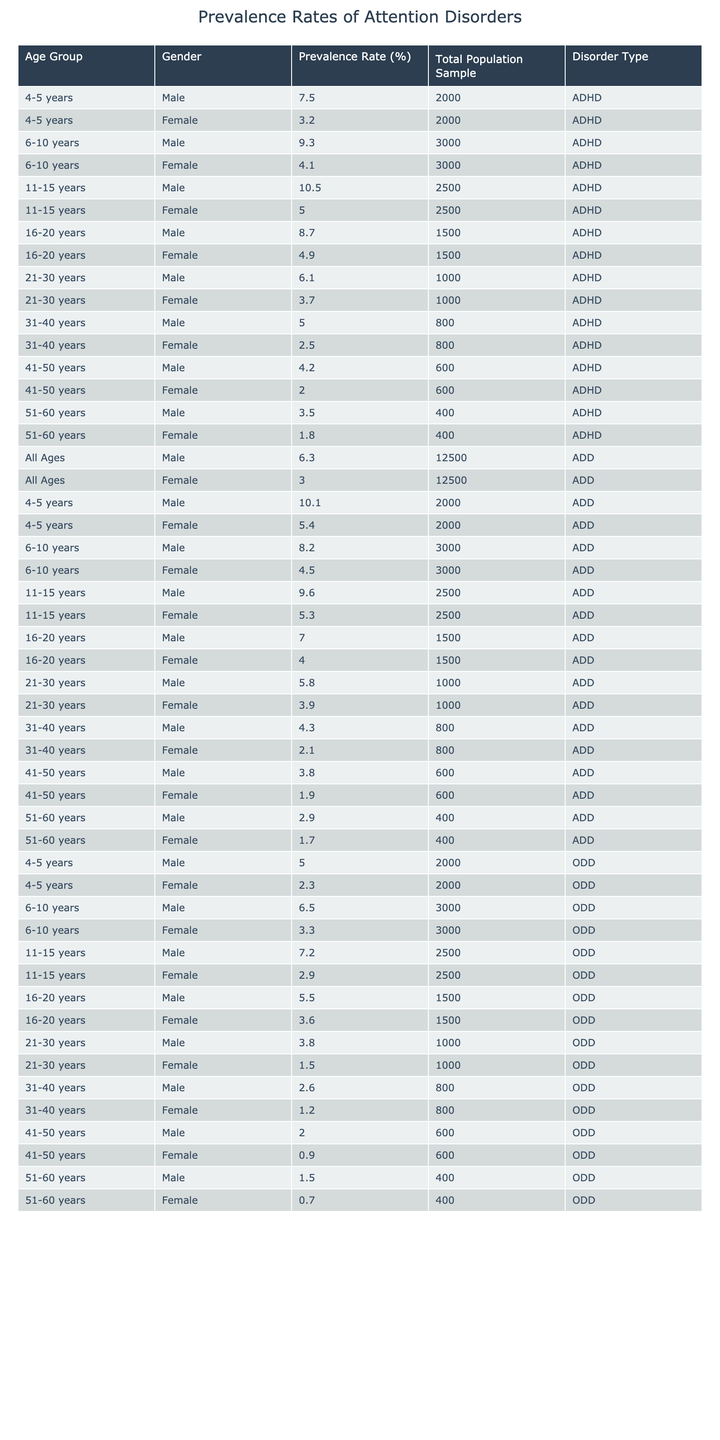What is the prevalence rate of ADHD in males aged 6-10 years? From the table, the prevalence rate of ADHD for males in the age group 6-10 years is listed as 9.3%.
Answer: 9.3% What is the total population sample for females aged 11-15 years with ADD? For females in the 11-15 years age group, the total population sample for ADD is 2500.
Answer: 2500 Which gender has a higher prevalence rate of ODD in the 4-5 years age group? For the 4-5 years age group, males have a prevalence rate of 5.0% for ODD, while females have a prevalence rate of 2.3%. Since 5.0% > 2.3%, males have a higher prevalence rate.
Answer: Males What is the average prevalence rate of ADHD across all age groups for females? To find the average, sum the prevalence rates for females (3.2, 4.1, 5.0, 4.9, 3.7, 2.5, 2.0, 1.8) = 25.2, then divide by the number of entries (8). 25.2 / 8 = 3.15.
Answer: 3.15 Is it true that the prevalence rate of ADD in males aged 51-60 years is higher than that in females of the same age group? The prevalence rate of ADD for males aged 51-60 is 2.9%, while for females it is 1.7%. Since 2.9% > 1.7%, it is true that males have a higher prevalence rate.
Answer: Yes What is the difference in prevalence rates of ODD between males and females in the 16-20 years age group? The prevalence rate of ODD for males in the 16-20 years age group is 5.5%, and for females, it is 3.6%. The difference is 5.5% - 3.6% = 1.9%.
Answer: 1.9% For which age group do males have the lowest prevalence rate of ADHD? Looking at the prevalence rates of ADHD for males, the lowest value is 4.2% for the 41-50 years age group.
Answer: 41-50 years What is the combined prevalence rate of ADD for both genders in the 21-30 years age group? The prevalence rate for males in the 21-30 years age group is 5.8%, and for females, it is 3.9%. Combining these gives 5.8% + 3.9% = 9.7%.
Answer: 9.7% How many age groups have a prevalence rate of ADHD above 8% for males? The age groups where the prevalence rate of ADHD for males is above 8% are 4-5 years (7.5% not counted), 6-10 years (9.3%), 11-15 years (10.5%), and 16-20 years (8.7%). That totals to 4 age groups.
Answer: 4 What is the prevalence rate of ADD in females aged 31-40 years? The table shows that the prevalence rate of ADD for females in the 31-40 years age group is 2.1%.
Answer: 2.1% Which disorder type has a higher average prevalence rate, ADHD or ODD, for males? Calculate the average prevalence for ADHD males: (7.5 + 9.3 + 10.5 + 8.7 + 6.1 + 5.0 + 4.2 + 3.5) / 8 = 6.6%. For ODD males: (5.0 + 6.5 + 7.2 + 5.5 + 3.8 + 2.6 + 2.0 + 1.5) / 8 = 4.3%. Since 6.6% > 4.3%, ADHD has a higher average.
Answer: ADHD 